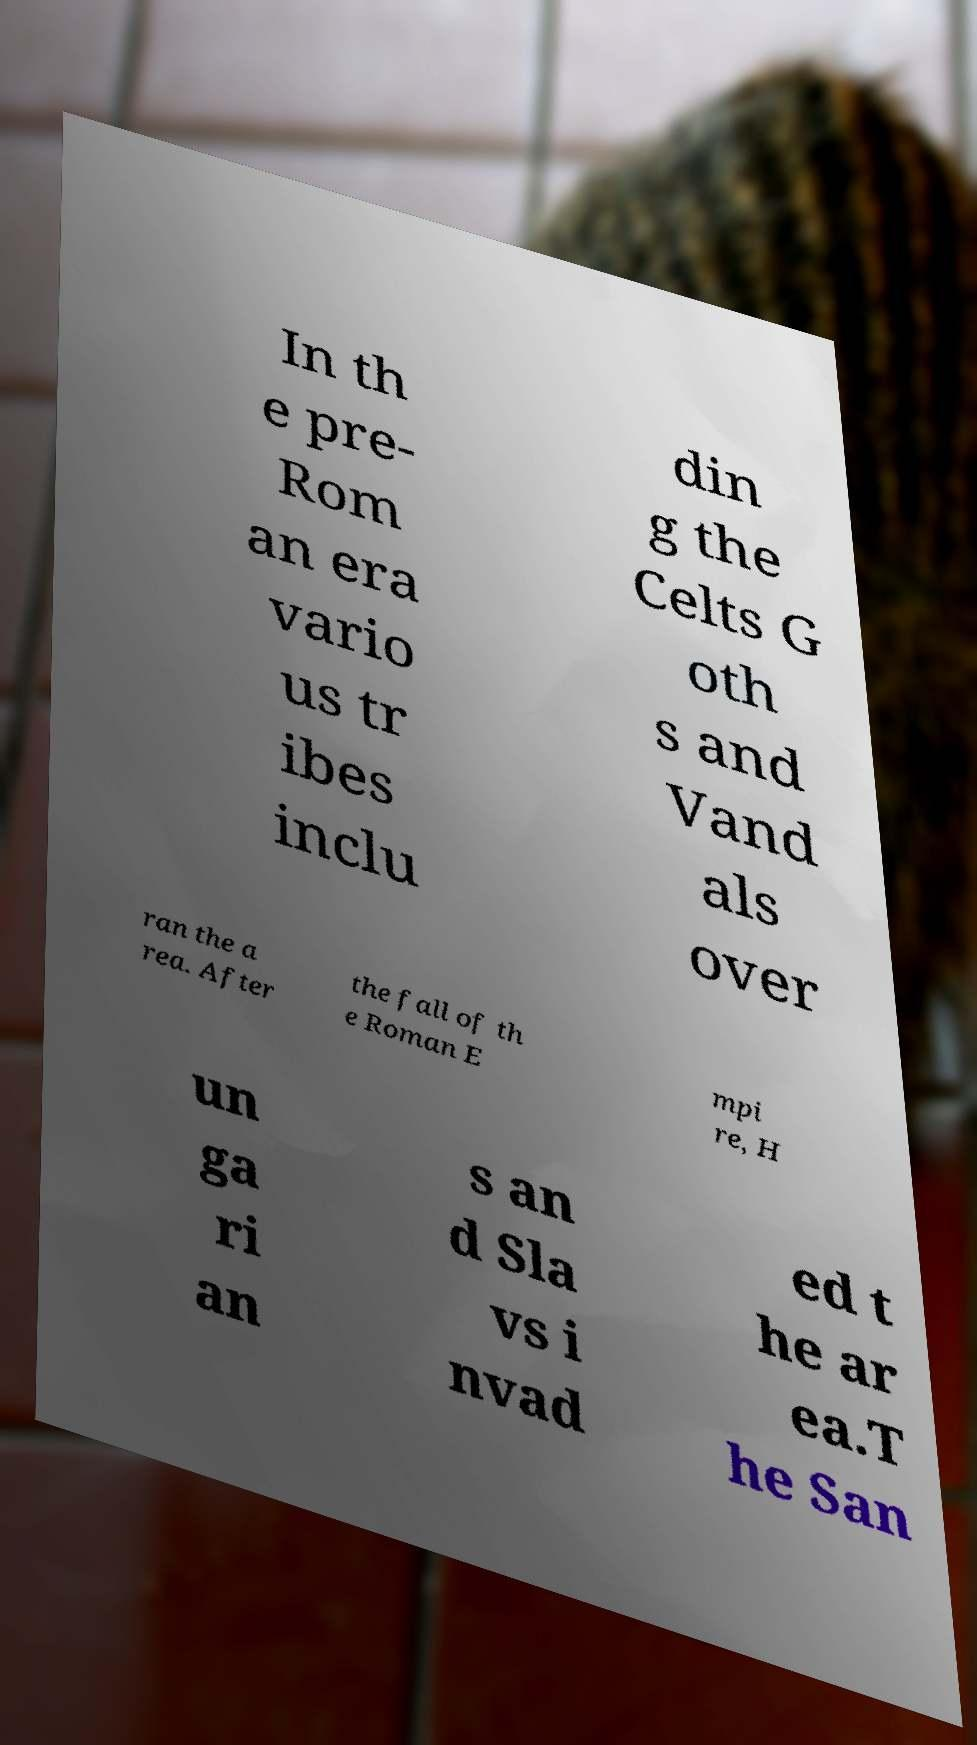I need the written content from this picture converted into text. Can you do that? In th e pre- Rom an era vario us tr ibes inclu din g the Celts G oth s and Vand als over ran the a rea. After the fall of th e Roman E mpi re, H un ga ri an s an d Sla vs i nvad ed t he ar ea.T he San 